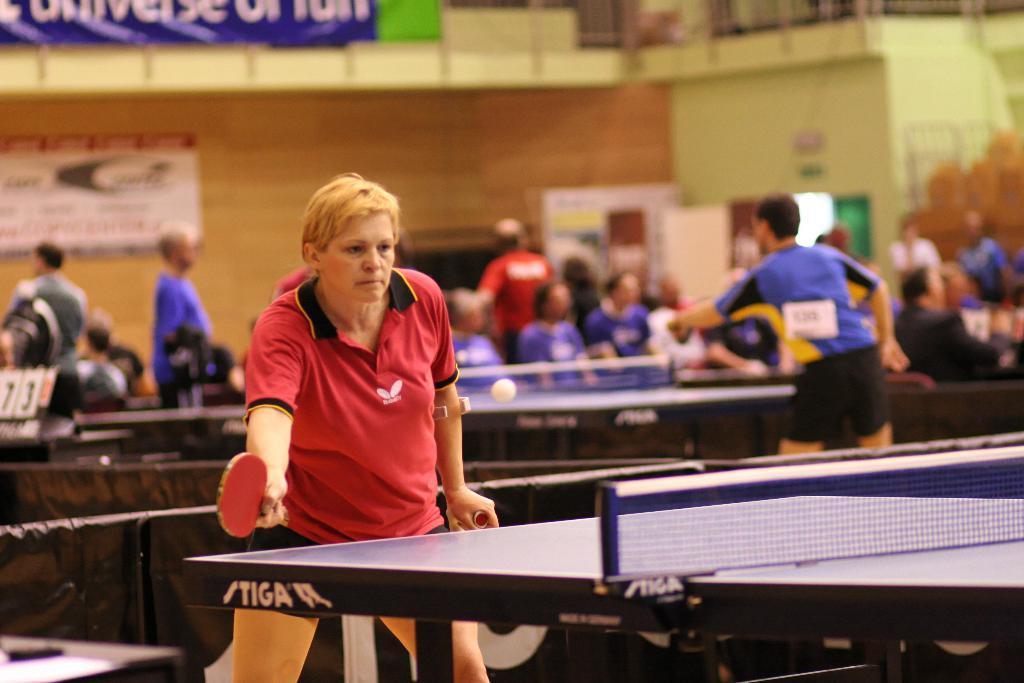Can you describe this image briefly? It is sports area or sports room, an athlete is playing table tennis behind her there are also other people they are also playing the same game i,n the background there is a wooden wall. 